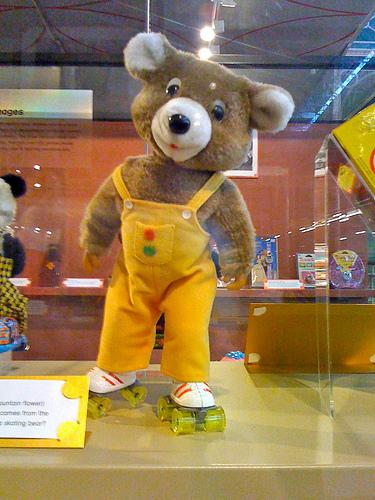Question: what is in the window?
Choices:
A. Cat.
B. Bear.
C. Dog.
D. Tiger.
Answer with the letter. Answer: B Question: what color is the bear?
Choices:
A. Black.
B. Gray.
C. Brown.
D. White.
Answer with the letter. Answer: C Question: what color is the bear's overalls?
Choices:
A. Blue.
B. Brown.
C. Gray.
D. Yellow.
Answer with the letter. Answer: D Question: what is on the bear's feet?
Choices:
A. Sandals.
B. High heels.
C. Skates.
D. Cowboy boots.
Answer with the letter. Answer: C Question: what is the bear's expression?
Choices:
A. Smiling.
B. Laughing.
C. Frowning.
D. Crying.
Answer with the letter. Answer: A 